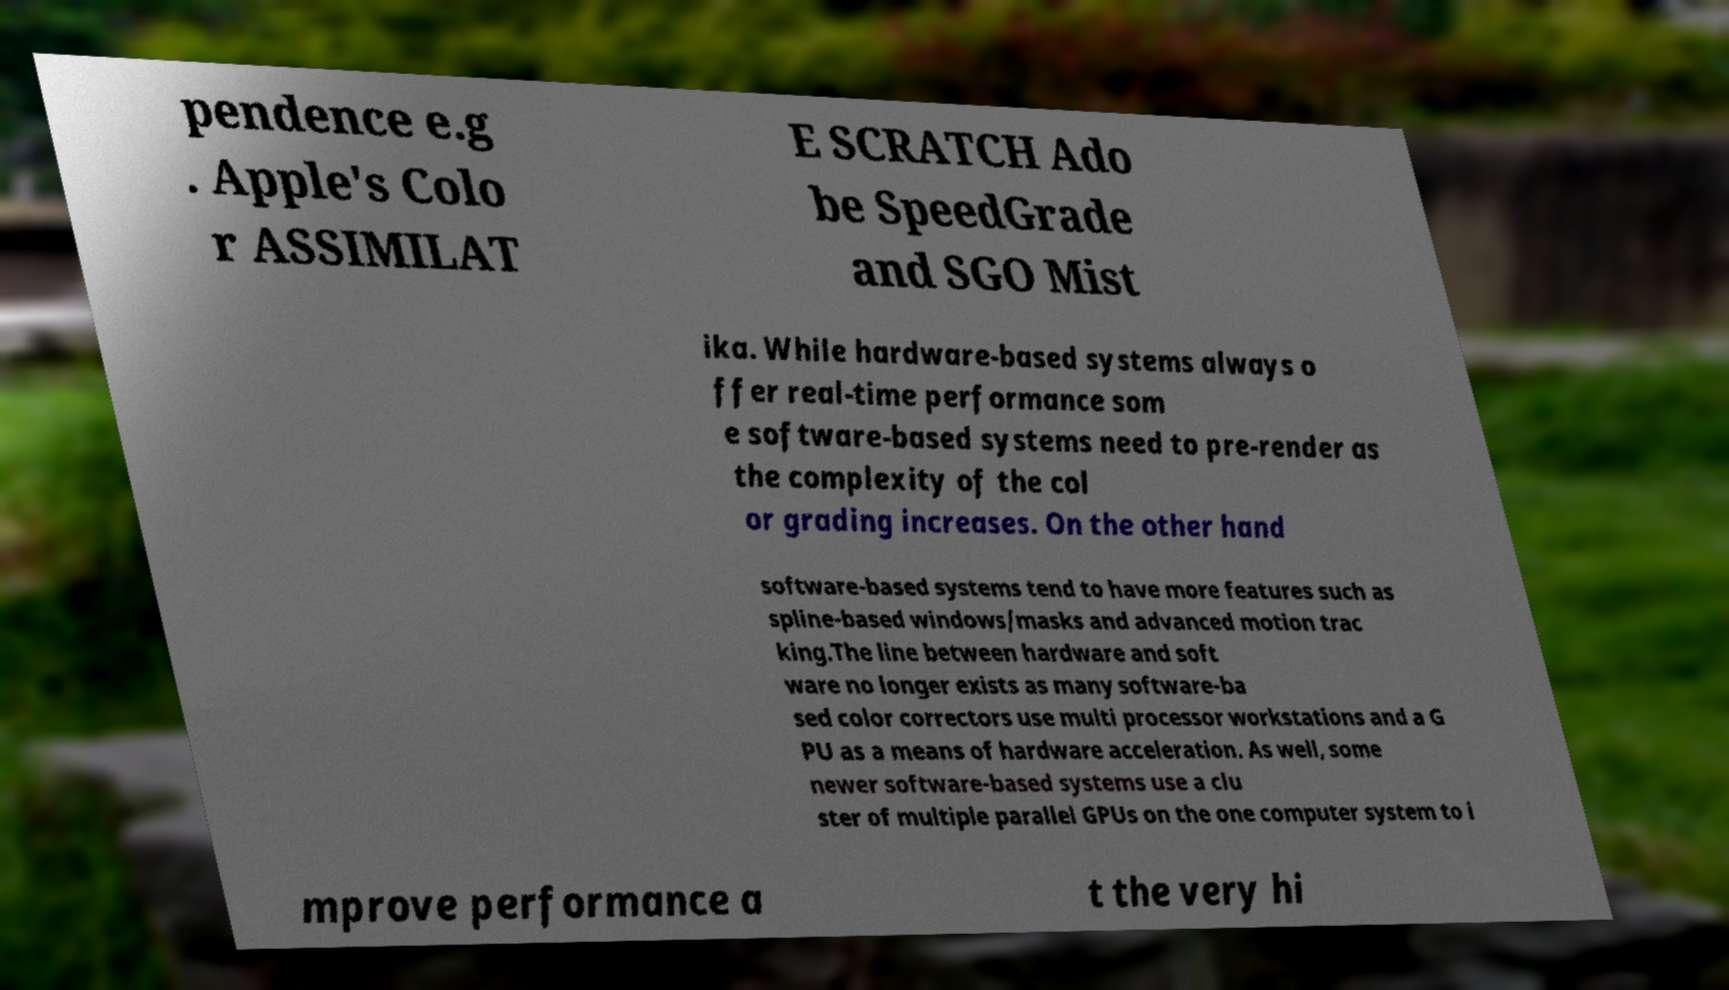Can you read and provide the text displayed in the image?This photo seems to have some interesting text. Can you extract and type it out for me? pendence e.g . Apple's Colo r ASSIMILAT E SCRATCH Ado be SpeedGrade and SGO Mist ika. While hardware-based systems always o ffer real-time performance som e software-based systems need to pre-render as the complexity of the col or grading increases. On the other hand software-based systems tend to have more features such as spline-based windows/masks and advanced motion trac king.The line between hardware and soft ware no longer exists as many software-ba sed color correctors use multi processor workstations and a G PU as a means of hardware acceleration. As well, some newer software-based systems use a clu ster of multiple parallel GPUs on the one computer system to i mprove performance a t the very hi 